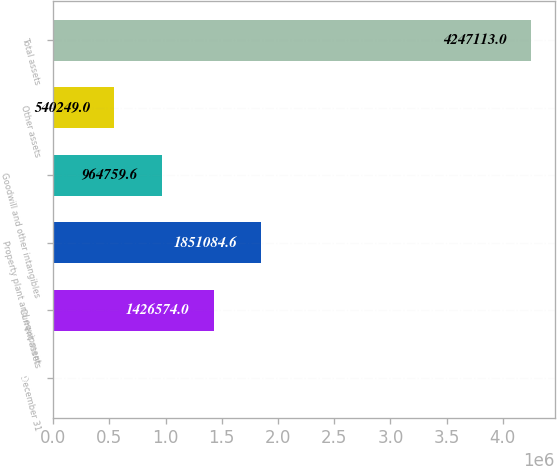Convert chart to OTSL. <chart><loc_0><loc_0><loc_500><loc_500><bar_chart><fcel>December 31<fcel>Current assets<fcel>Property plant and equipment<fcel>Goodwill and other intangibles<fcel>Other assets<fcel>Total assets<nl><fcel>2007<fcel>1.42657e+06<fcel>1.85108e+06<fcel>964760<fcel>540249<fcel>4.24711e+06<nl></chart> 